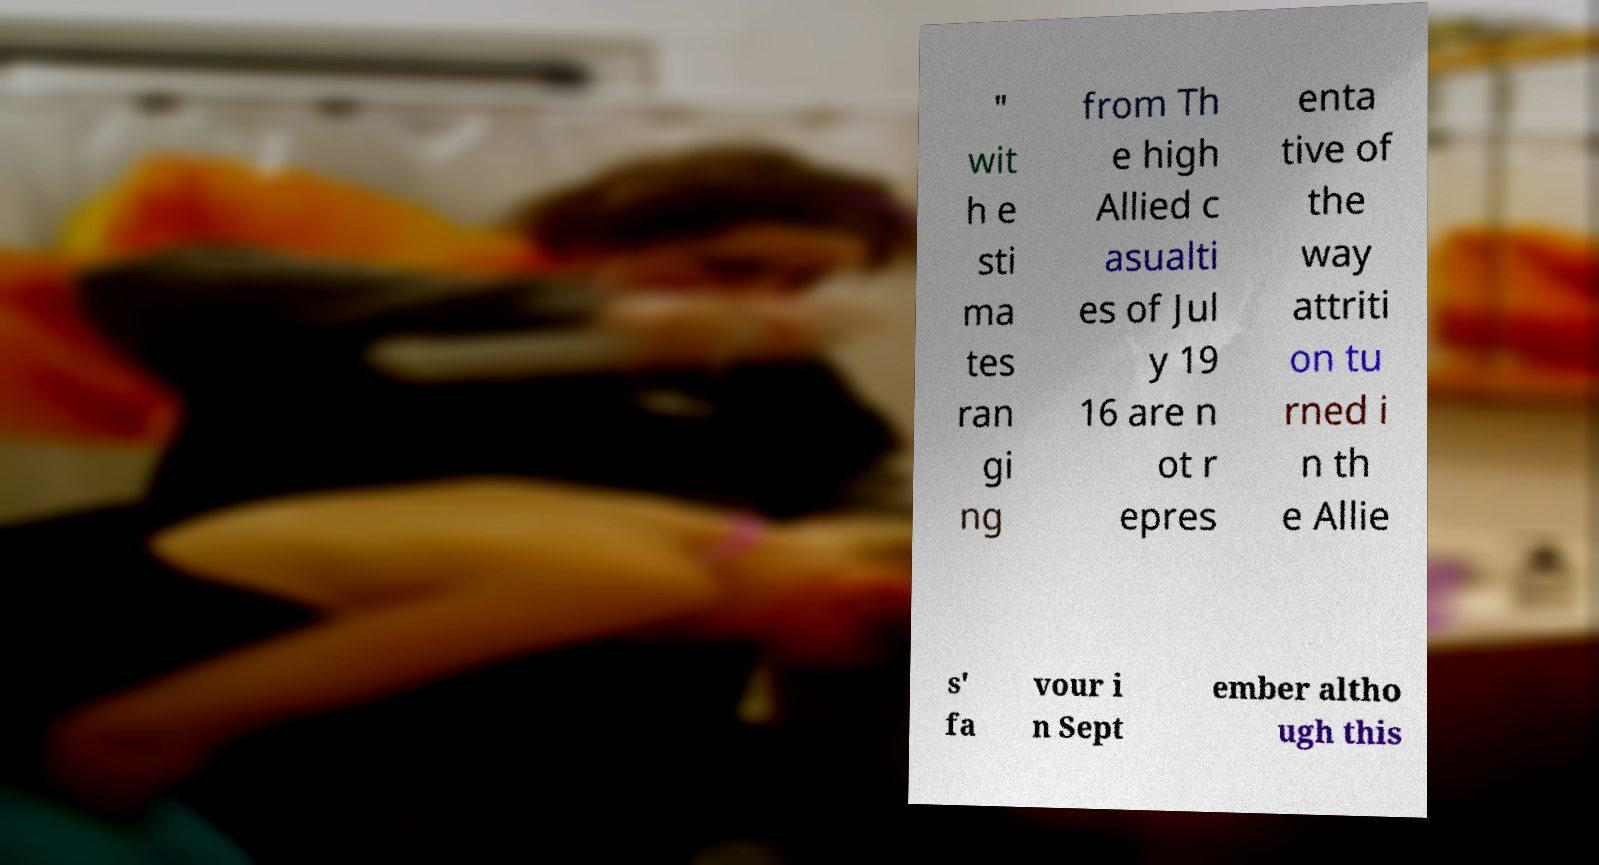For documentation purposes, I need the text within this image transcribed. Could you provide that? " wit h e sti ma tes ran gi ng from Th e high Allied c asualti es of Jul y 19 16 are n ot r epres enta tive of the way attriti on tu rned i n th e Allie s' fa vour i n Sept ember altho ugh this 